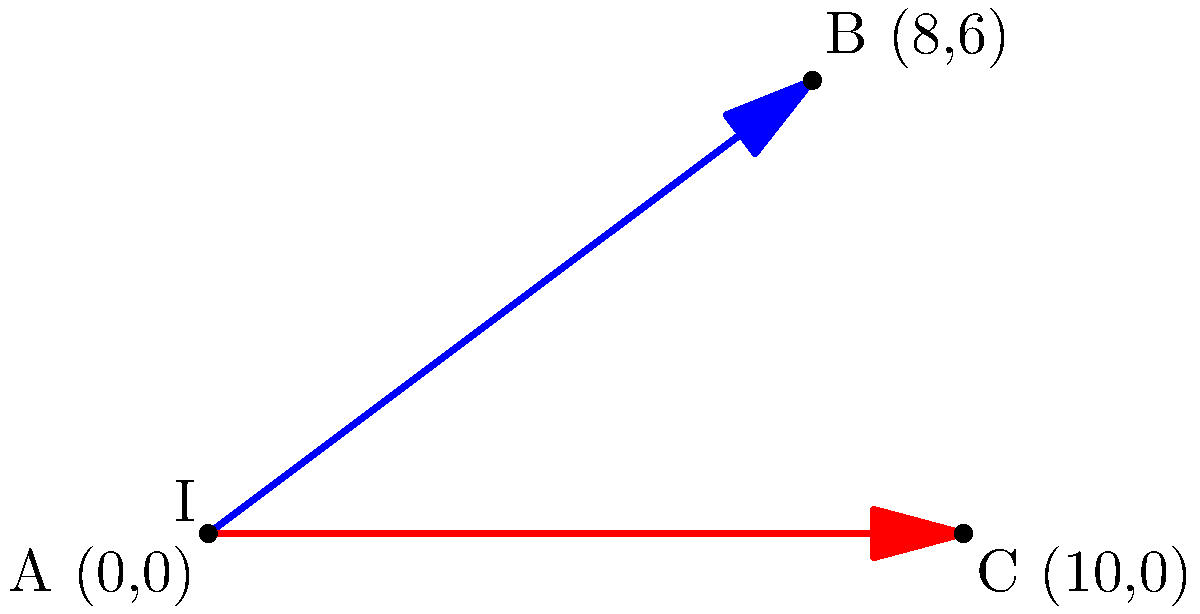During the Civil War, two supply routes intersect on a coordinate plane. The Union supply route runs from point A (0,0) to point B (8,6), while the Confederate supply route runs from point A (0,0) to point C (10,0). At what coordinates do these supply routes intersect? Round your answer to two decimal places. To find the intersection point of the two supply routes, we need to follow these steps:

1) First, let's find the equations of both lines:

   For the Union route (AB):
   Slope = $m_{AB} = \frac{6-0}{8-0} = \frac{3}{4}$
   Equation: $y = \frac{3}{4}x$

   For the Confederate route (AC):
   Slope = $m_{AC} = \frac{0-0}{10-0} = 0$
   Equation: $y = 0$

2) The intersection point is where these two equations are equal:

   $\frac{3}{4}x = 0$

3) Solving for x:
   $x = 0$

4) Substituting this x-value back into either equation:
   $y = \frac{3}{4}(0) = 0$

5) Therefore, the intersection point is (0,0), which is actually point A.

However, this result doesn't make sense in the context of the problem, as the routes are diverging from point A. Let's consider the lines as rays instead of infinite lines.

6) For the Union route: $y = \frac{3}{4}x$ for $0 \leq x \leq 8$
   For the Confederate route: $y = 0$ for $0 \leq x \leq 10$

7) The intersection point will be where $y = 0$ on the Union route (excluding A):
   $0 = \frac{3}{4}x$
   $x = 0$

   This again gives us point A, which we've established isn't the answer we're looking for.

8) Therefore, we can conclude that these supply routes, when considered as rays, do not intersect after diverging from point A.
Answer: The supply routes do not intersect after diverging from point A (0,0). 